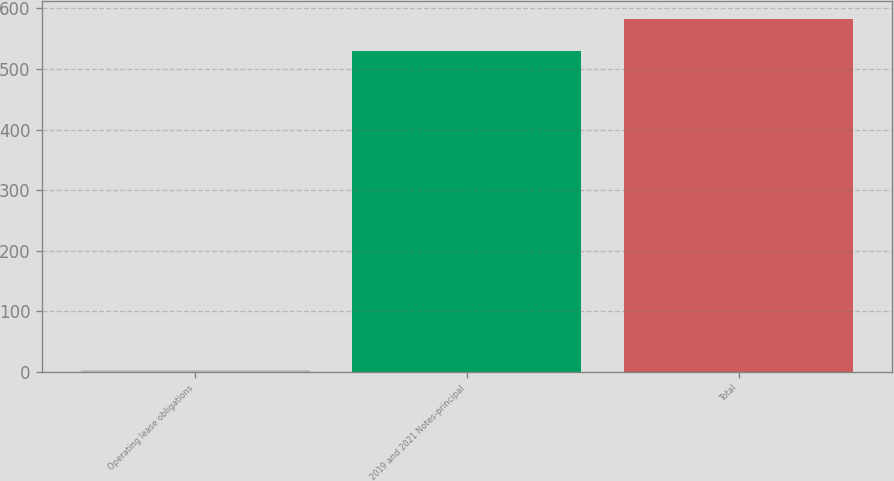<chart> <loc_0><loc_0><loc_500><loc_500><bar_chart><fcel>Operating lease obligations<fcel>2019 and 2021 Notes-principal<fcel>Total<nl><fcel>3.5<fcel>529.4<fcel>582.84<nl></chart> 